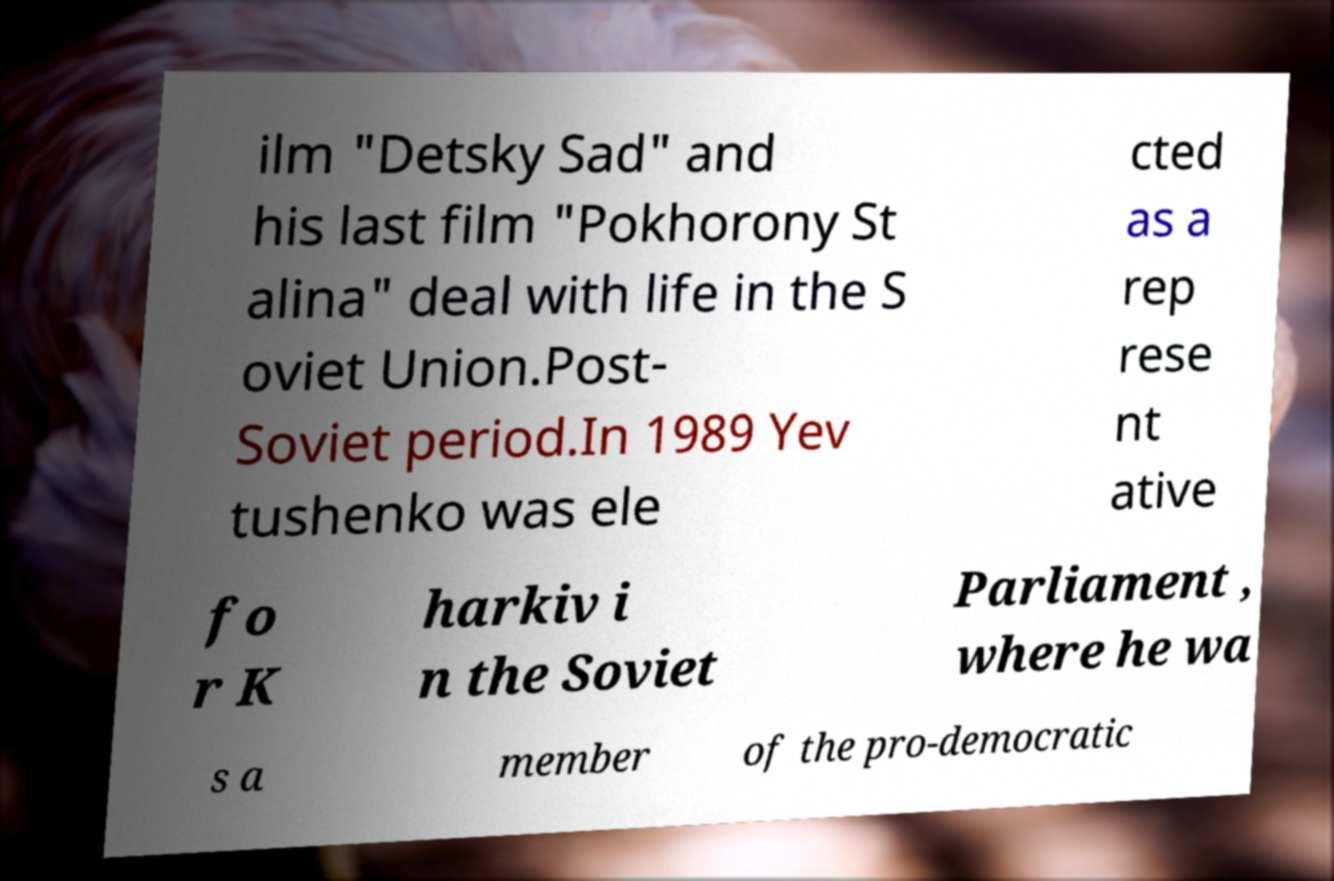I need the written content from this picture converted into text. Can you do that? ilm "Detsky Sad" and his last film "Pokhorony St alina" deal with life in the S oviet Union.Post- Soviet period.In 1989 Yev tushenko was ele cted as a rep rese nt ative fo r K harkiv i n the Soviet Parliament , where he wa s a member of the pro-democratic 